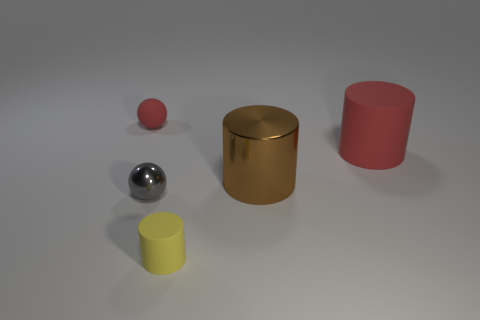There is a yellow thing that is the same shape as the big brown thing; what is its material?
Ensure brevity in your answer.  Rubber. Are there an equal number of brown objects that are on the left side of the big metallic thing and large metallic spheres?
Your response must be concise. Yes. There is a thing that is both on the right side of the tiny yellow rubber object and on the left side of the big rubber thing; what size is it?
Offer a very short reply. Large. Is there anything else that has the same color as the small matte ball?
Keep it short and to the point. Yes. There is a red matte thing behind the thing right of the metal cylinder; how big is it?
Keep it short and to the point. Small. The tiny object that is to the left of the yellow cylinder and to the right of the tiny matte sphere is what color?
Give a very brief answer. Gray. How many other things are there of the same size as the metal cylinder?
Keep it short and to the point. 1. Does the yellow thing have the same size as the red thing in front of the small red matte thing?
Your answer should be compact. No. What color is the metal object that is the same size as the red matte sphere?
Your response must be concise. Gray. The yellow object has what size?
Ensure brevity in your answer.  Small. 